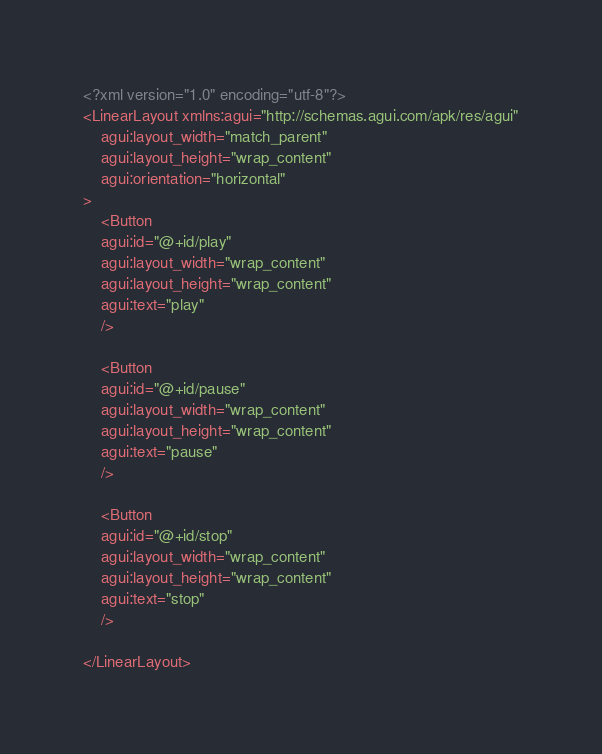<code> <loc_0><loc_0><loc_500><loc_500><_XML_><?xml version="1.0" encoding="utf-8"?>
<LinearLayout xmlns:agui="http://schemas.agui.com/apk/res/agui"
	agui:layout_width="match_parent"
	agui:layout_height="wrap_content"
	agui:orientation="horizontal"
>
	<Button
	agui:id="@+id/play"
	agui:layout_width="wrap_content"
	agui:layout_height="wrap_content"
	agui:text="play"
	/>
	
	<Button
	agui:id="@+id/pause"
	agui:layout_width="wrap_content"
	agui:layout_height="wrap_content"
	agui:text="pause"
	/>
	
	<Button
	agui:id="@+id/stop"
	agui:layout_width="wrap_content"
	agui:layout_height="wrap_content"
	agui:text="stop"
	/>
	
</LinearLayout></code> 